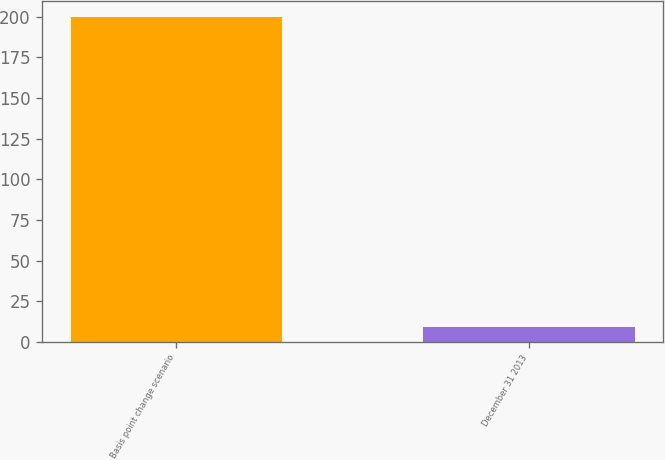Convert chart. <chart><loc_0><loc_0><loc_500><loc_500><bar_chart><fcel>Basis point change scenario<fcel>December 31 2013<nl><fcel>200<fcel>9.3<nl></chart> 